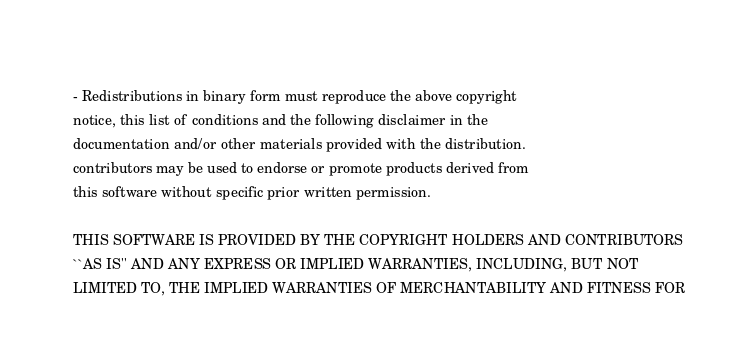Convert code to text. <code><loc_0><loc_0><loc_500><loc_500><_C_>   
   - Redistributions in binary form must reproduce the above copyright
   notice, this list of conditions and the following disclaimer in the
   documentation and/or other materials provided with the distribution.
   contributors may be used to endorse or promote products derived from
   this software without specific prior written permission.
   
   THIS SOFTWARE IS PROVIDED BY THE COPYRIGHT HOLDERS AND CONTRIBUTORS
   ``AS IS'' AND ANY EXPRESS OR IMPLIED WARRANTIES, INCLUDING, BUT NOT
   LIMITED TO, THE IMPLIED WARRANTIES OF MERCHANTABILITY AND FITNESS FOR</code> 